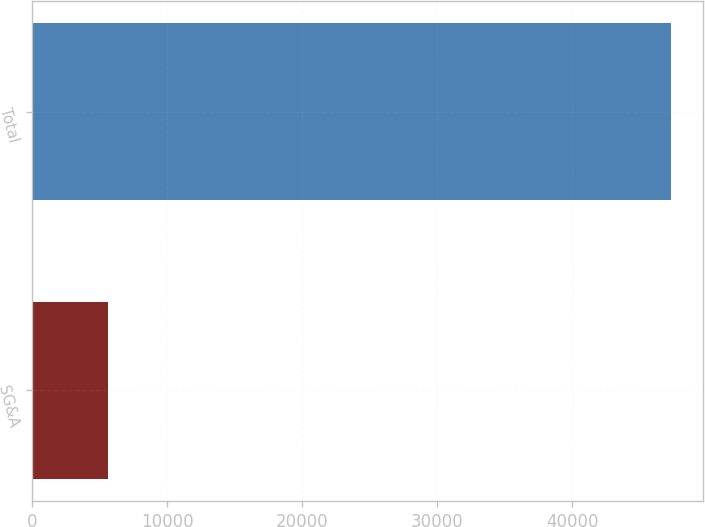<chart> <loc_0><loc_0><loc_500><loc_500><bar_chart><fcel>SG&A<fcel>Total<nl><fcel>5616<fcel>47314<nl></chart> 